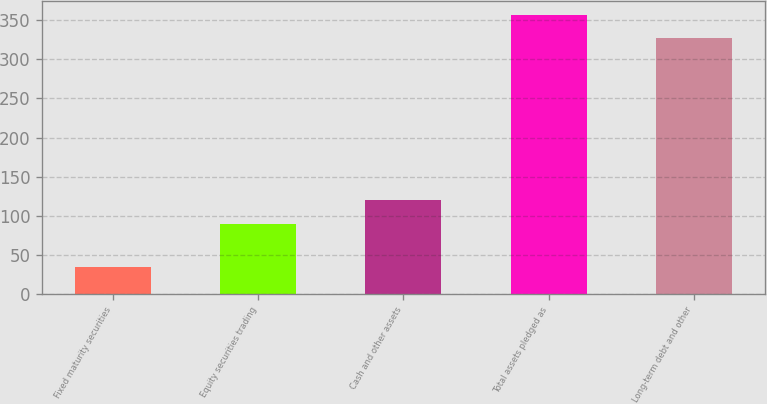<chart> <loc_0><loc_0><loc_500><loc_500><bar_chart><fcel>Fixed maturity securities<fcel>Equity securities trading<fcel>Cash and other assets<fcel>Total assets pledged as<fcel>Long-term debt and other<nl><fcel>34.7<fcel>90.1<fcel>120.11<fcel>357.21<fcel>327.2<nl></chart> 